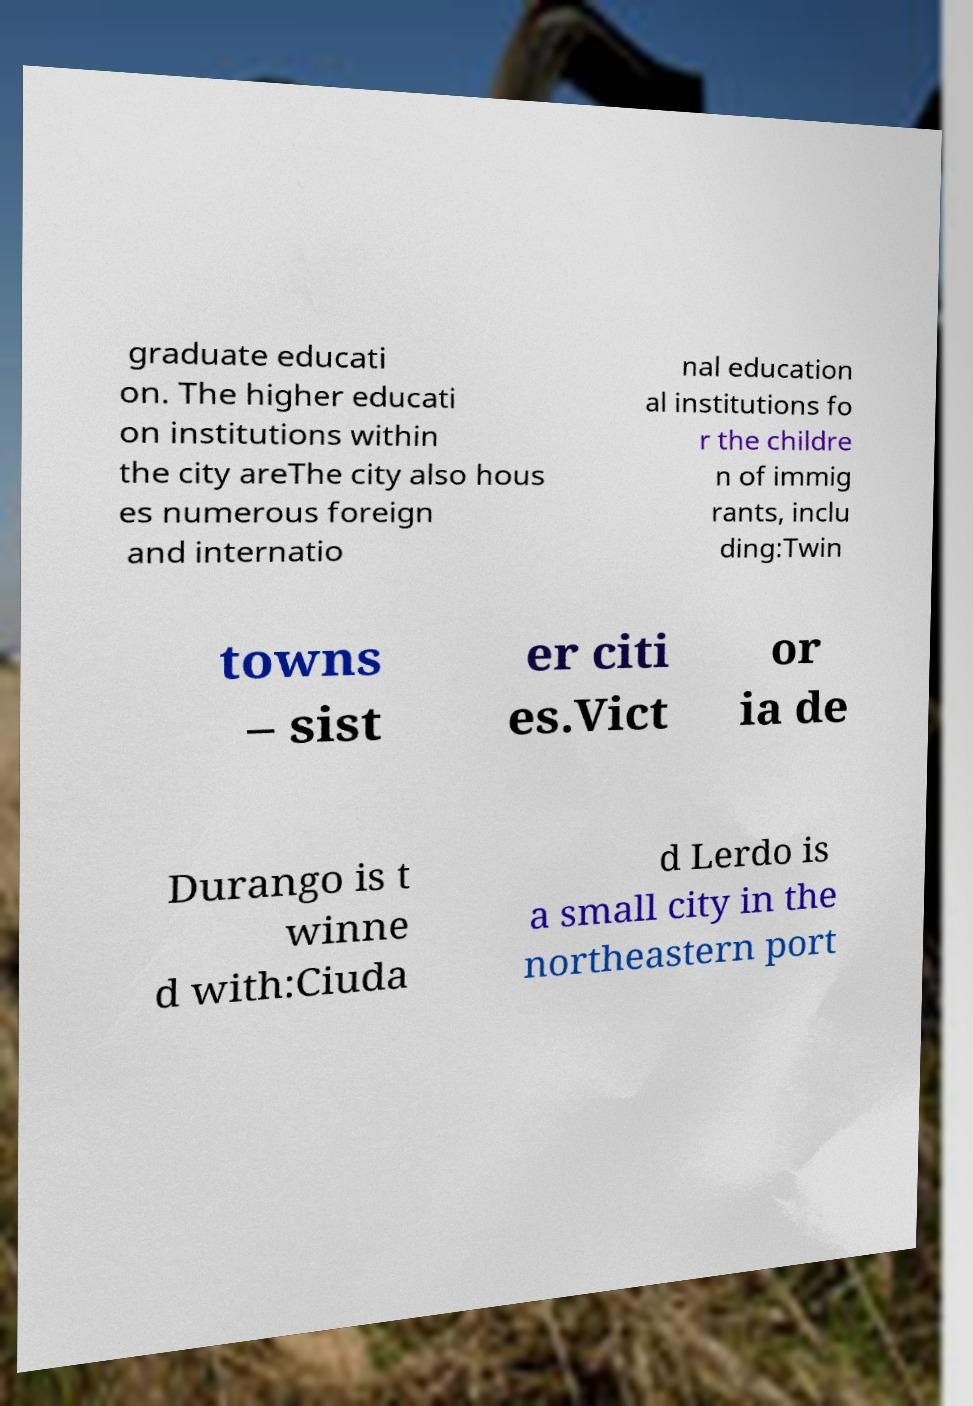Could you assist in decoding the text presented in this image and type it out clearly? graduate educati on. The higher educati on institutions within the city areThe city also hous es numerous foreign and internatio nal education al institutions fo r the childre n of immig rants, inclu ding:Twin towns – sist er citi es.Vict or ia de Durango is t winne d with:Ciuda d Lerdo is a small city in the northeastern port 